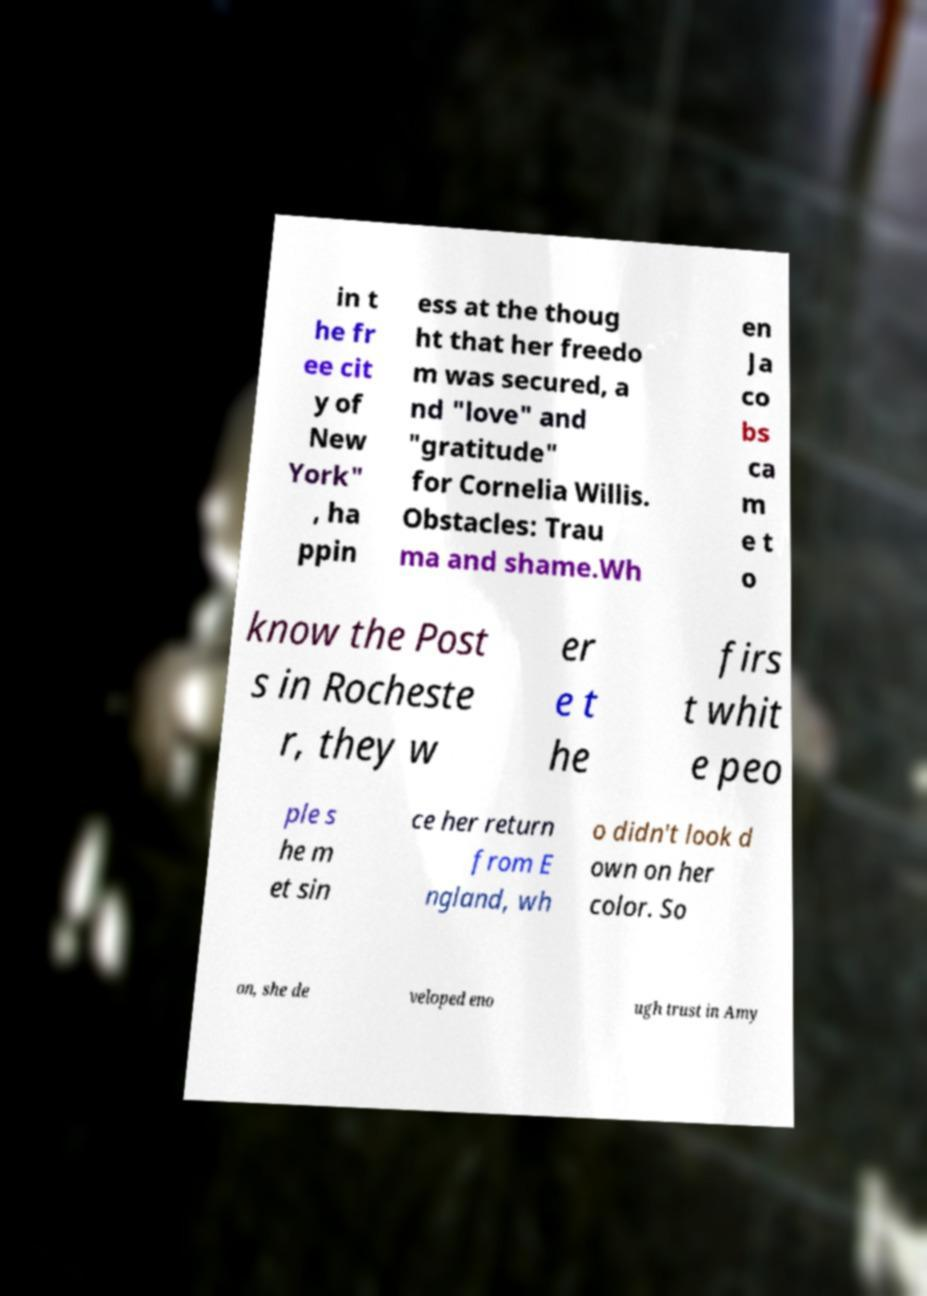I need the written content from this picture converted into text. Can you do that? in t he fr ee cit y of New York" , ha ppin ess at the thoug ht that her freedo m was secured, a nd "love" and "gratitude" for Cornelia Willis. Obstacles: Trau ma and shame.Wh en Ja co bs ca m e t o know the Post s in Rocheste r, they w er e t he firs t whit e peo ple s he m et sin ce her return from E ngland, wh o didn't look d own on her color. So on, she de veloped eno ugh trust in Amy 